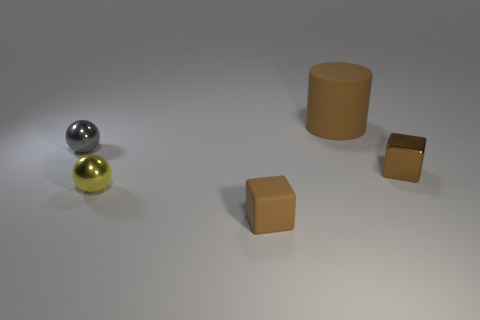Does the matte thing in front of the big rubber object have the same color as the big cylinder?
Offer a terse response. Yes. How many balls are either tiny yellow objects or big rubber things?
Make the answer very short. 1. There is a thing to the right of the matte thing that is behind the small cube that is in front of the brown metal object; how big is it?
Your response must be concise. Small. What shape is the gray metal thing that is the same size as the yellow metal thing?
Ensure brevity in your answer.  Sphere. The big matte thing is what shape?
Make the answer very short. Cylinder. Does the small cube behind the small yellow metal object have the same material as the big brown cylinder?
Provide a short and direct response. No. What is the size of the metallic object that is in front of the small object that is right of the tiny rubber thing?
Ensure brevity in your answer.  Small. What is the color of the object that is both behind the brown shiny object and in front of the large brown thing?
Make the answer very short. Gray. There is a gray ball that is the same size as the yellow object; what material is it?
Make the answer very short. Metal. How many other things are the same material as the large brown object?
Keep it short and to the point. 1. 